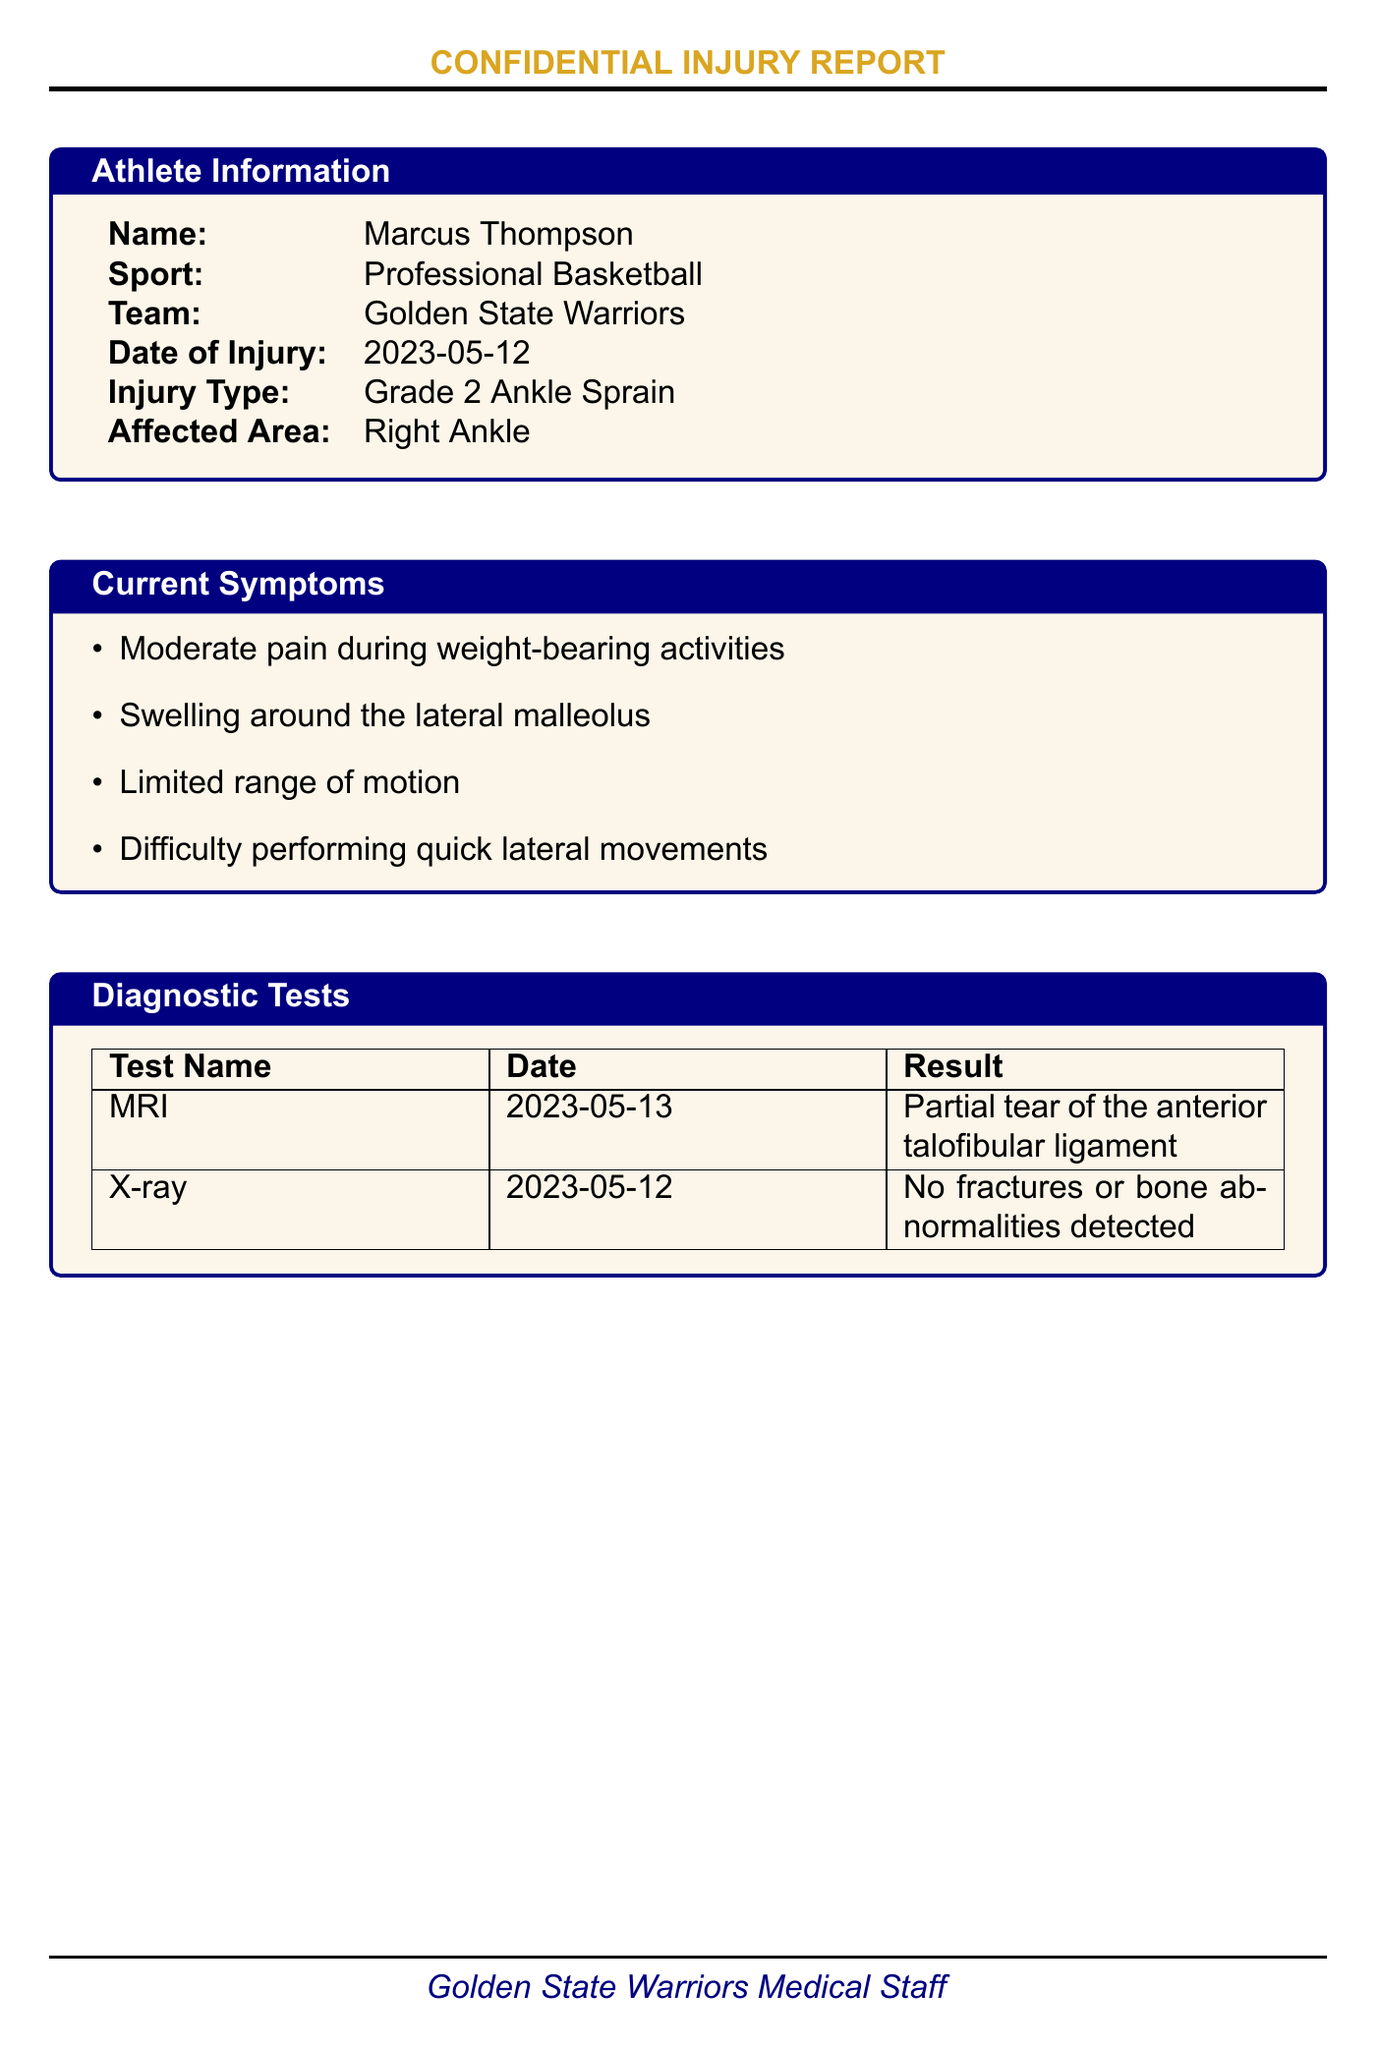what is the name of the athlete? The athlete's name is provided in the documentation under athlete information.
Answer: Marcus Thompson what is the type of injury? The injury type is listed in the document's athlete information section.
Answer: Grade 2 Ankle Sprain when did the injury occur? The date of injury is specified in the athlete information section of the document.
Answer: 2023-05-12 what is the estimated return to play? The estimated return to play is detailed under additional information.
Answer: 4-6 weeks who is the head athletic trainer? The medical team section lists the names and roles of the medical staff.
Answer: Sarah Johnson what procedures are included in the acute phase of the treatment plan? The acute phase treatment plan is specifically outlined in the treatment plan section of the document.
Answer: RICE protocol, Non-weight bearing, Anti-inflammatory medication how long is the rehabilitation phase expected to last? The duration of the rehabilitation phase is mentioned in the treatment plan.
Answer: 2-6 weeks what special consideration is mentioned regarding rehabilitation? Special considerations for rehabilitation are included in the additional information section.
Answer: Monitor for signs of re-injury what diagnostic test was performed on 2023-05-13? The diagnostic tests section provides the date and type of diagnostic tests performed.
Answer: MRI what is the confidentiality note regarding the injury report? The confidentiality note section specifies the rules regarding sharing the injury report.
Answer: This injury report is strictly confidential 